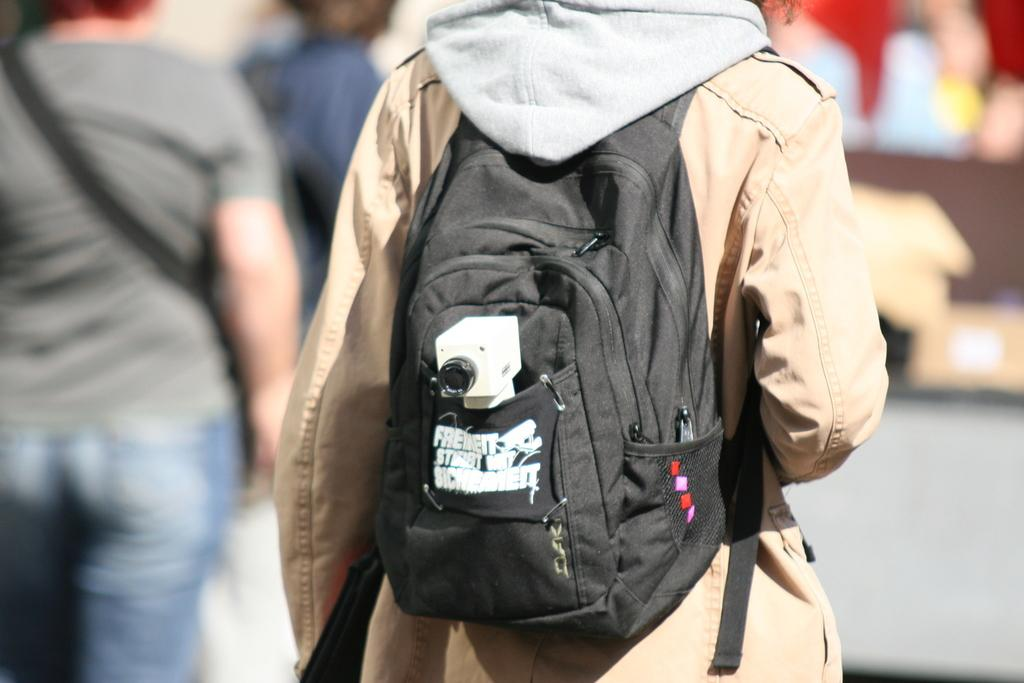How many people are in the image? There are people in the image. Can you describe the person in the middle? The person in the middle is hanging a black color backpack and wearing a sand color coat. What is the person in the middle doing? The person in the middle is hanging a black color backpack. What type of berry can be seen growing on the person in the middle? There are no berries present on the person in the middle; they are hanging a backpack and wearing a coat. 